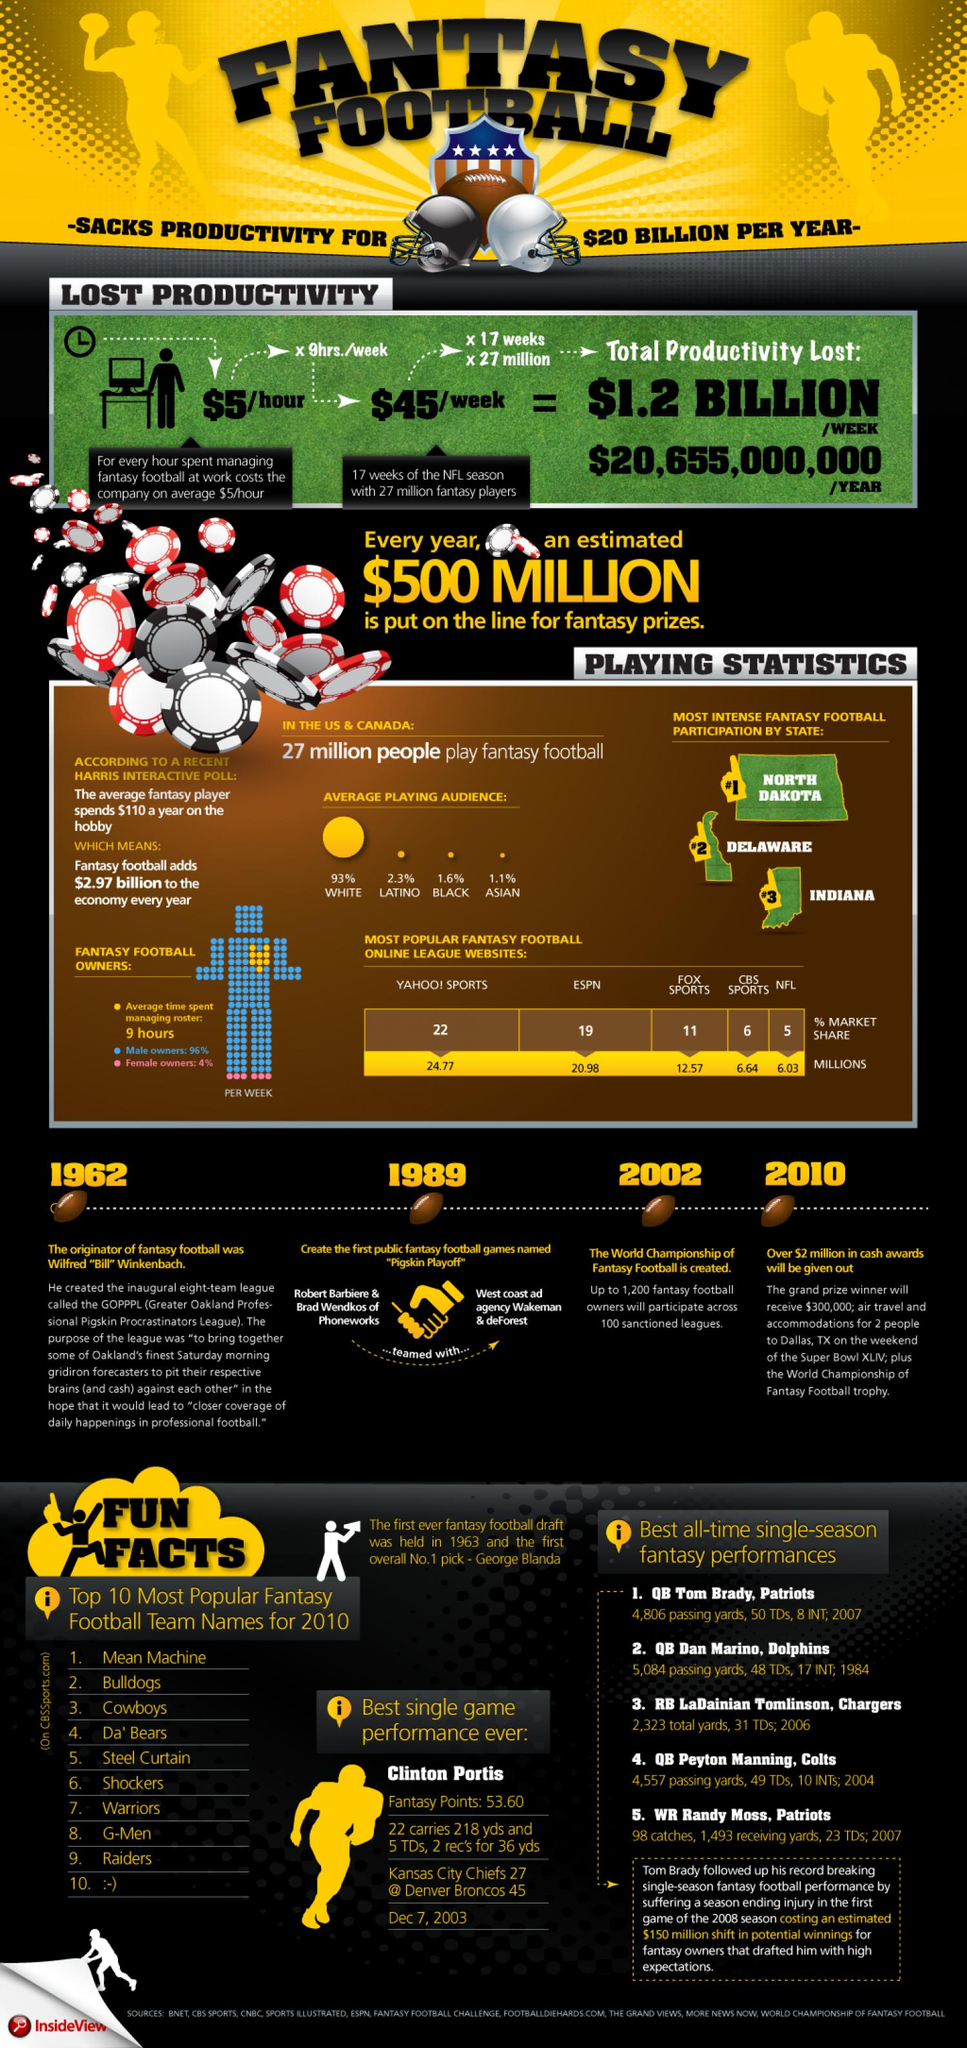Indicate a few pertinent items in this graphic. The Pigskin Playoff was created in the year 1989. It can be declared that North Dakota, Delaware, and Indiana are the states with the most intense fantasy football participation. In the year 2002, the world championship of fantasy football was established. 